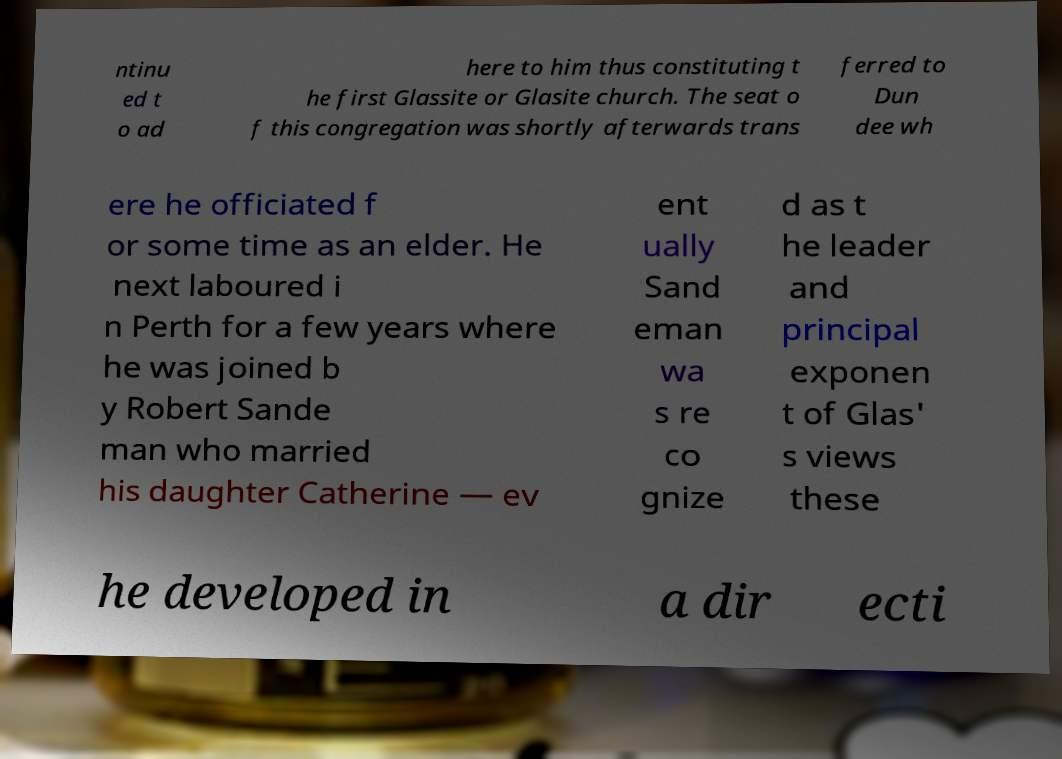Please identify and transcribe the text found in this image. ntinu ed t o ad here to him thus constituting t he first Glassite or Glasite church. The seat o f this congregation was shortly afterwards trans ferred to Dun dee wh ere he officiated f or some time as an elder. He next laboured i n Perth for a few years where he was joined b y Robert Sande man who married his daughter Catherine — ev ent ually Sand eman wa s re co gnize d as t he leader and principal exponen t of Glas' s views these he developed in a dir ecti 